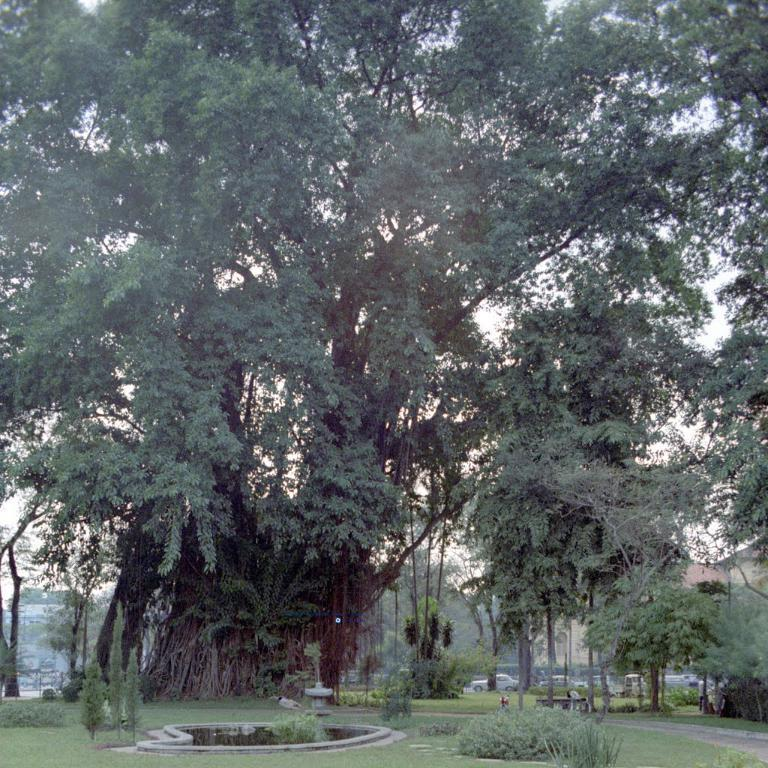What is the main feature of the image? There is a road in the image. What type of vegetation can be seen in the image? There is grass and plants visible in the image. What is moving along the road in the image? There are vehicles on the road. What else can be seen in the image besides the road and vehicles? There are trees in the image. What is visible in the background of the image? The sky is visible in the background of the image. What type of lettuce is being used to take pictures of the vehicles in the image? There is no lettuce or camera present in the image, and therefore no such activity can be observed. 